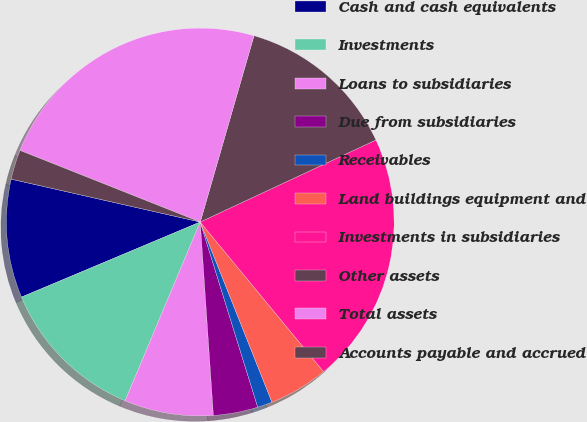Convert chart. <chart><loc_0><loc_0><loc_500><loc_500><pie_chart><fcel>Cash and cash equivalents<fcel>Investments<fcel>Loans to subsidiaries<fcel>Due from subsidiaries<fcel>Receivables<fcel>Land buildings equipment and<fcel>Investments in subsidiaries<fcel>Other assets<fcel>Total assets<fcel>Accounts payable and accrued<nl><fcel>9.88%<fcel>12.34%<fcel>7.41%<fcel>3.71%<fcel>1.24%<fcel>4.94%<fcel>20.98%<fcel>13.58%<fcel>23.45%<fcel>2.47%<nl></chart> 